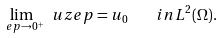Convert formula to latex. <formula><loc_0><loc_0><loc_500><loc_500>\lim _ { \ e p \to 0 ^ { + } } \ u z e p = u _ { 0 } \quad i n L ^ { 2 } ( \Omega ) .</formula> 